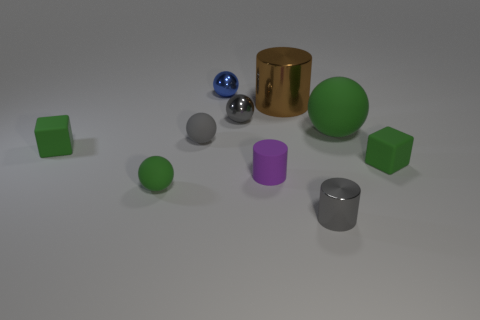Subtract all green rubber spheres. How many spheres are left? 3 Subtract all green blocks. How many green spheres are left? 2 Subtract all blue balls. How many balls are left? 4 Subtract 1 spheres. How many spheres are left? 4 Subtract all blocks. How many objects are left? 8 Subtract all blue spheres. Subtract all brown cylinders. How many spheres are left? 4 Subtract 0 cyan cylinders. How many objects are left? 10 Subtract all rubber blocks. Subtract all tiny cylinders. How many objects are left? 6 Add 2 big green rubber spheres. How many big green rubber spheres are left? 3 Add 3 small gray rubber things. How many small gray rubber things exist? 4 